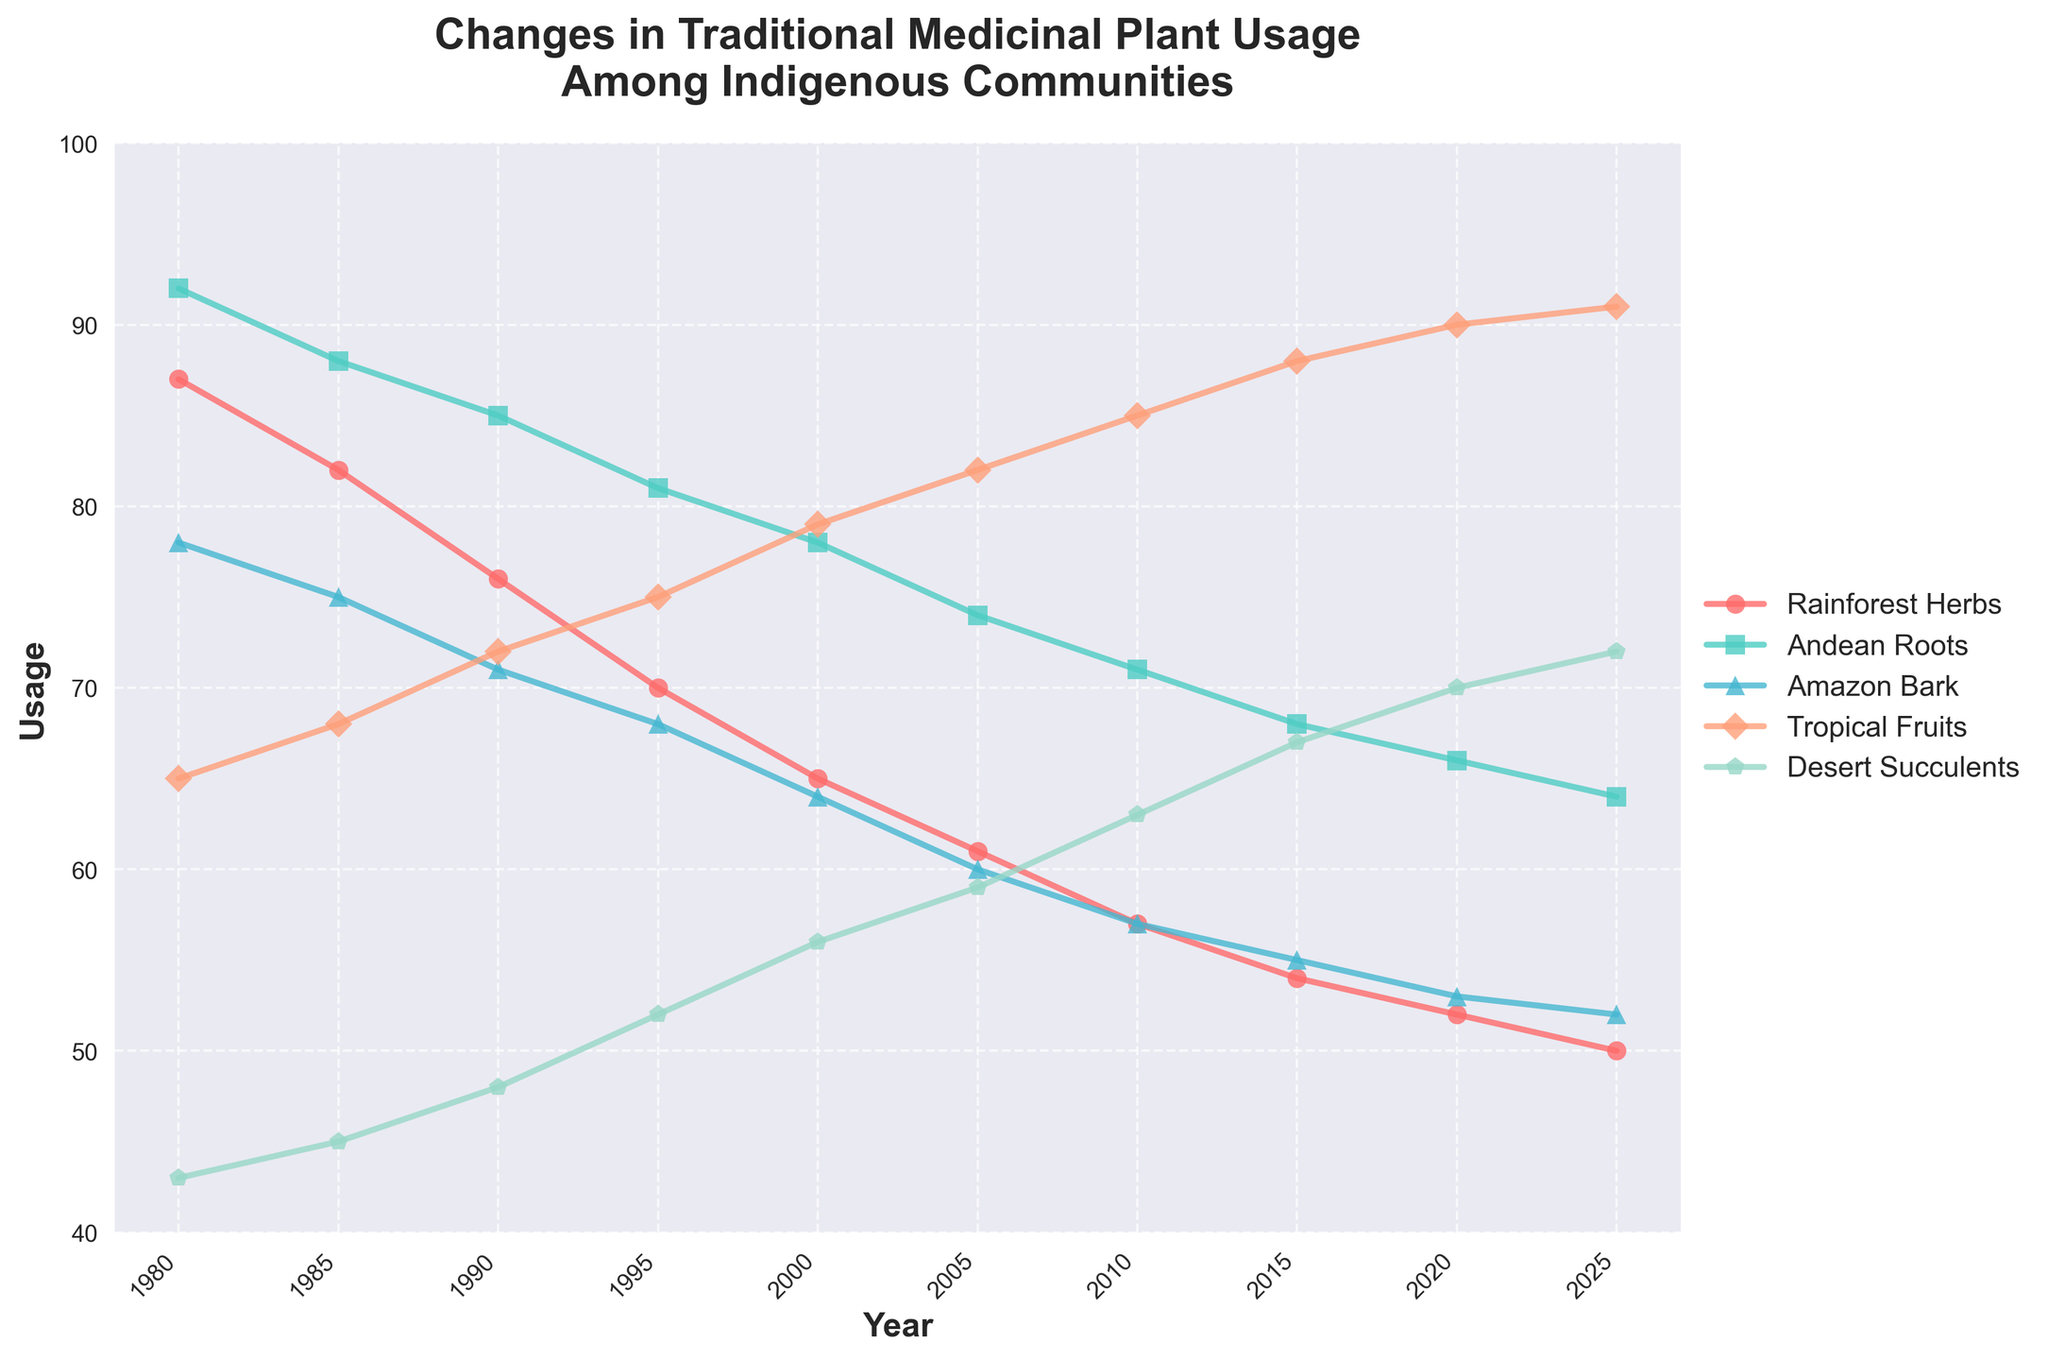What trend is observed for Rainforest Herbs over the years? The usage of Rainforest Herbs shows a consistent decline from 87 in 1980 to 50 in 2025.
Answer: Decline Which plant type experienced the highest final usage in 2025? By comparing the final usage values for all plant types in 2025, Tropical Fruits have the highest usage at 91.
Answer: Tropical Fruits By how much did the usage of Desert Succulents increase from 1980 to 2025? The usage of Desert Succulents in 1980 was 43 and increased to 72 in 2025. The difference is 72 - 43 = 29.
Answer: 29 Which two plant types showed the closest usage values in 2025? In 2025, the usage values are: Rainforest Herbs (50), Andean Roots (64), Amazon Bark (52), Tropical Fruits (91), Desert Succulents (72). The closest values are for Amazon Bark and Rainforest Herbs, differing by only 2 (52 - 50).
Answer: Amazon Bark and Rainforest Herbs What was the average usage of Andean Roots in 1985 and 2015? The usage of Andean Roots in 1985 was 88 and in 2015 was 68. The average is (88 + 68) / 2 = 78.
Answer: 78 Which plant type had a steady increase in usage throughout the timeline? By observing the trends, only Tropical Fruits show a steady increase from 65 in 1980 to 91 in 2025 without any decrease.
Answer: Tropical Fruits How does the visual representation of Amazon Bark usage compare to Desert Succulents in 1990? The line for Amazon Bark in 1990 hits 71, which is below Desert Succulents at 48. Both are represented with distinct markers and lines, but Amazon Bark is shown as higher in the chart’s y-axis.
Answer: Higher for Amazon Bark Which plant types' usage values crossed each other, and when did it happen? The usage lines for Andean Roots and Rainforest Herbs cross between the data points for 1980 and 1985, where Rainforest Herbs declines below Andean Roots. And also, Tropical Fruits and Andean Roots cross between 1995 and 2000.
Answer: Andean Roots and Rainforest Herbs (1980-1985), Tropical Fruits and Andean Roots (1995-2000) What is the least used plant type in 2010, and what is its usage? In 2010, the least used plant type is Amazon Bark with a usage of 57.
Answer: Amazon Bark (57) By how much did the usage of Rainforest Herbs decrease per decade on average? From 1980 to 2025, Rainforest Herbs usage decreased from 87 to 50. The decrease is 87 - 50 = 37 over 45 years, which is approximately 37 / (45/10) = 8.22 per decade.
Answer: 8.22 per decade 